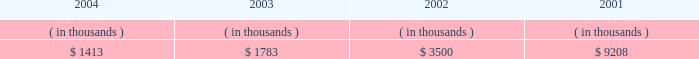Entergy new orleans , inc .
Management's financial discussion and analysis entergy new orleans' receivables from the money pool were as follows as of december 31 for each of the following years: .
Money pool activity provided $ 0.4 million of entergy new orleans' operating cash flow in 2004 , provided $ 1.7 million in 2003 , and provided $ 5.7 million in 2002 .
See note 4 to the domestic utility companies and system energy financial statements for a description of the money pool .
Investing activities net cash used in investing activities decreased $ 15.5 million in 2004 primarily due to capital expenditures related to a turbine inspection project at a fossil plant in 2003 and decreased customer service spending .
Net cash used in investing activities increased $ 23.2 million in 2003 compared to 2002 primarily due to the maturity of $ 14.9 million of other temporary investments in 2002 and increased construction expenditures due to increased customer service spending .
Financing activities net cash used in financing activities increased $ 7.0 million in 2004 primarily due to the costs and expenses related to refinancing $ 75 million of long-term debt in 2004 and an increase of $ 2.2 million in common stock dividends paid .
Net cash used in financing activities increased $ 1.5 million in 2003 primarily due to additional common stock dividends paid of $ 2.2 million .
In july 2003 , entergy new orleans issued $ 30 million of 3.875% ( 3.875 % ) series first mortgage bonds due august 2008 and $ 70 million of 5.25% ( 5.25 % ) series first mortgage bonds due august 2013 .
The proceeds from these issuances were used to redeem , prior to maturity , $ 30 million of 7% ( 7 % ) series first mortgage bonds due july 2008 , $ 40 million of 8% ( 8 % ) series bonds due march 2006 , and $ 30 million of 6.65% ( 6.65 % ) series first mortgage bonds due march 2004 .
The issuances and redemptions are not shown on the cash flow statement because the proceeds from the issuances were placed in a trust for use in the redemptions and never held as cash by entergy new orleans .
See note 5 to the domestic utility companies and system energy financial statements for details on long- term debt .
Uses of capital entergy new orleans requires capital resources for : 2022 construction and other capital investments ; 2022 debt and preferred stock maturities ; 2022 working capital purposes , including the financing of fuel and purchased power costs ; and 2022 dividend and interest payments. .
What is the annual interest expense related to the series first mortgage bonds due august 2008 , in millions? 
Computations: (30 * 3.875%)
Answer: 1.1625. 